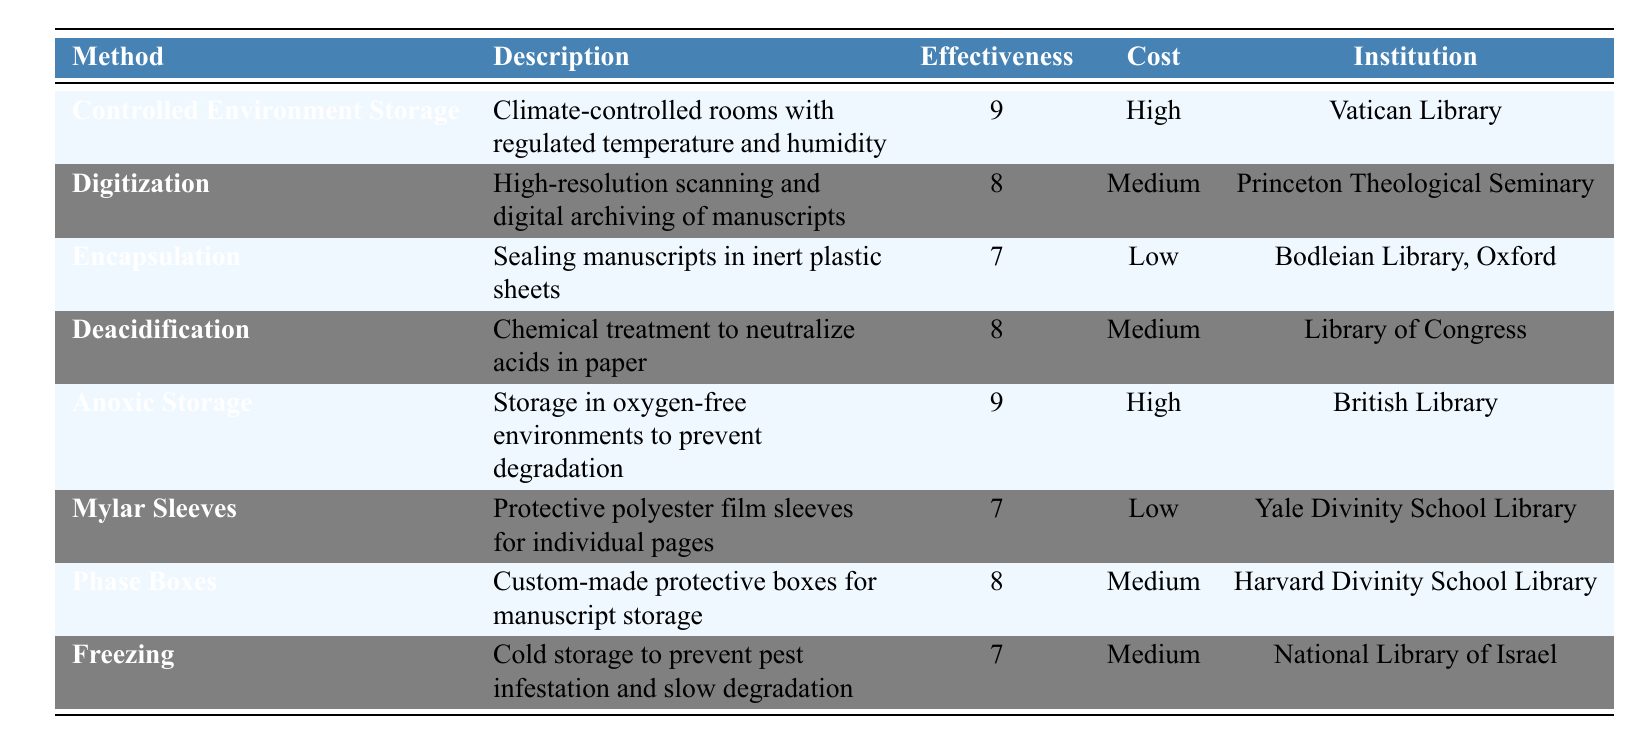What are the preservation methods used by the Vatican Library? The table lists the "PreservationMethods" and their corresponding institutions. The Vatican Library uses "Controlled Environment Storage."
Answer: Controlled Environment Storage Which method has the highest effectiveness rating? The table shows the effectiveness ratings for each preservation method. "Controlled Environment Storage" and "Anoxic Storage" both have the highest rating of 9.
Answer: Controlled Environment Storage, Anoxic Storage What is the cost level of digitization? The table provides the cost level for each preservation method. Digitization is listed with a cost level of "Medium."
Answer: Medium How many preservation methods have a low cost level? By examining the cost levels in the table, there are two methods listed as having a low cost level: "Encapsulation" and "Mylar Sleeves."
Answer: 2 Which preservation method is used by both the Library of Congress and the Bodleian Library, Oxford? The table does not list any method shared by these two institutions. The Library of Congress uses "Deacidification," while Bodleian Library, Oxford uses "Encapsulation." No method is common.
Answer: None What is the average effectiveness rating of preservation methods rated medium? The methods rated "Medium" are "Digitization," "Deacidification," "Phase Boxes," and "Freezing," with corresponding effectiveness ratings of 8, 8, 8, and 7. The average is (8 + 8 + 8 + 7) / 4 = 7.75.
Answer: 7.75 Is the cost level of "Anoxic Storage" high? The cost level for "Anoxic Storage" is listed as "High" in the table.
Answer: Yes Which preservation method has the lowest effectiveness rating and what is that rating? The table shows that "Encapsulation" and "Mylar Sleeves" both have the lowest effectiveness rating of 7.
Answer: 7 How does the effectiveness rating of "Phase Boxes" compare to "Mylar Sleeves"? The effectiveness rating for "Phase Boxes" is 8, whereas "Mylar Sleeves" has a rating of 7. Thus, "Phase Boxes" is more effective than "Mylar Sleeves."
Answer: More effective Which two institutions use preservation methods with the highest effectiveness ratings? "Controlled Environment Storage" (Vatican Library) and "Anoxic Storage" (British Library) both have an effectiveness rating of 9.
Answer: Vatican Library, British Library 